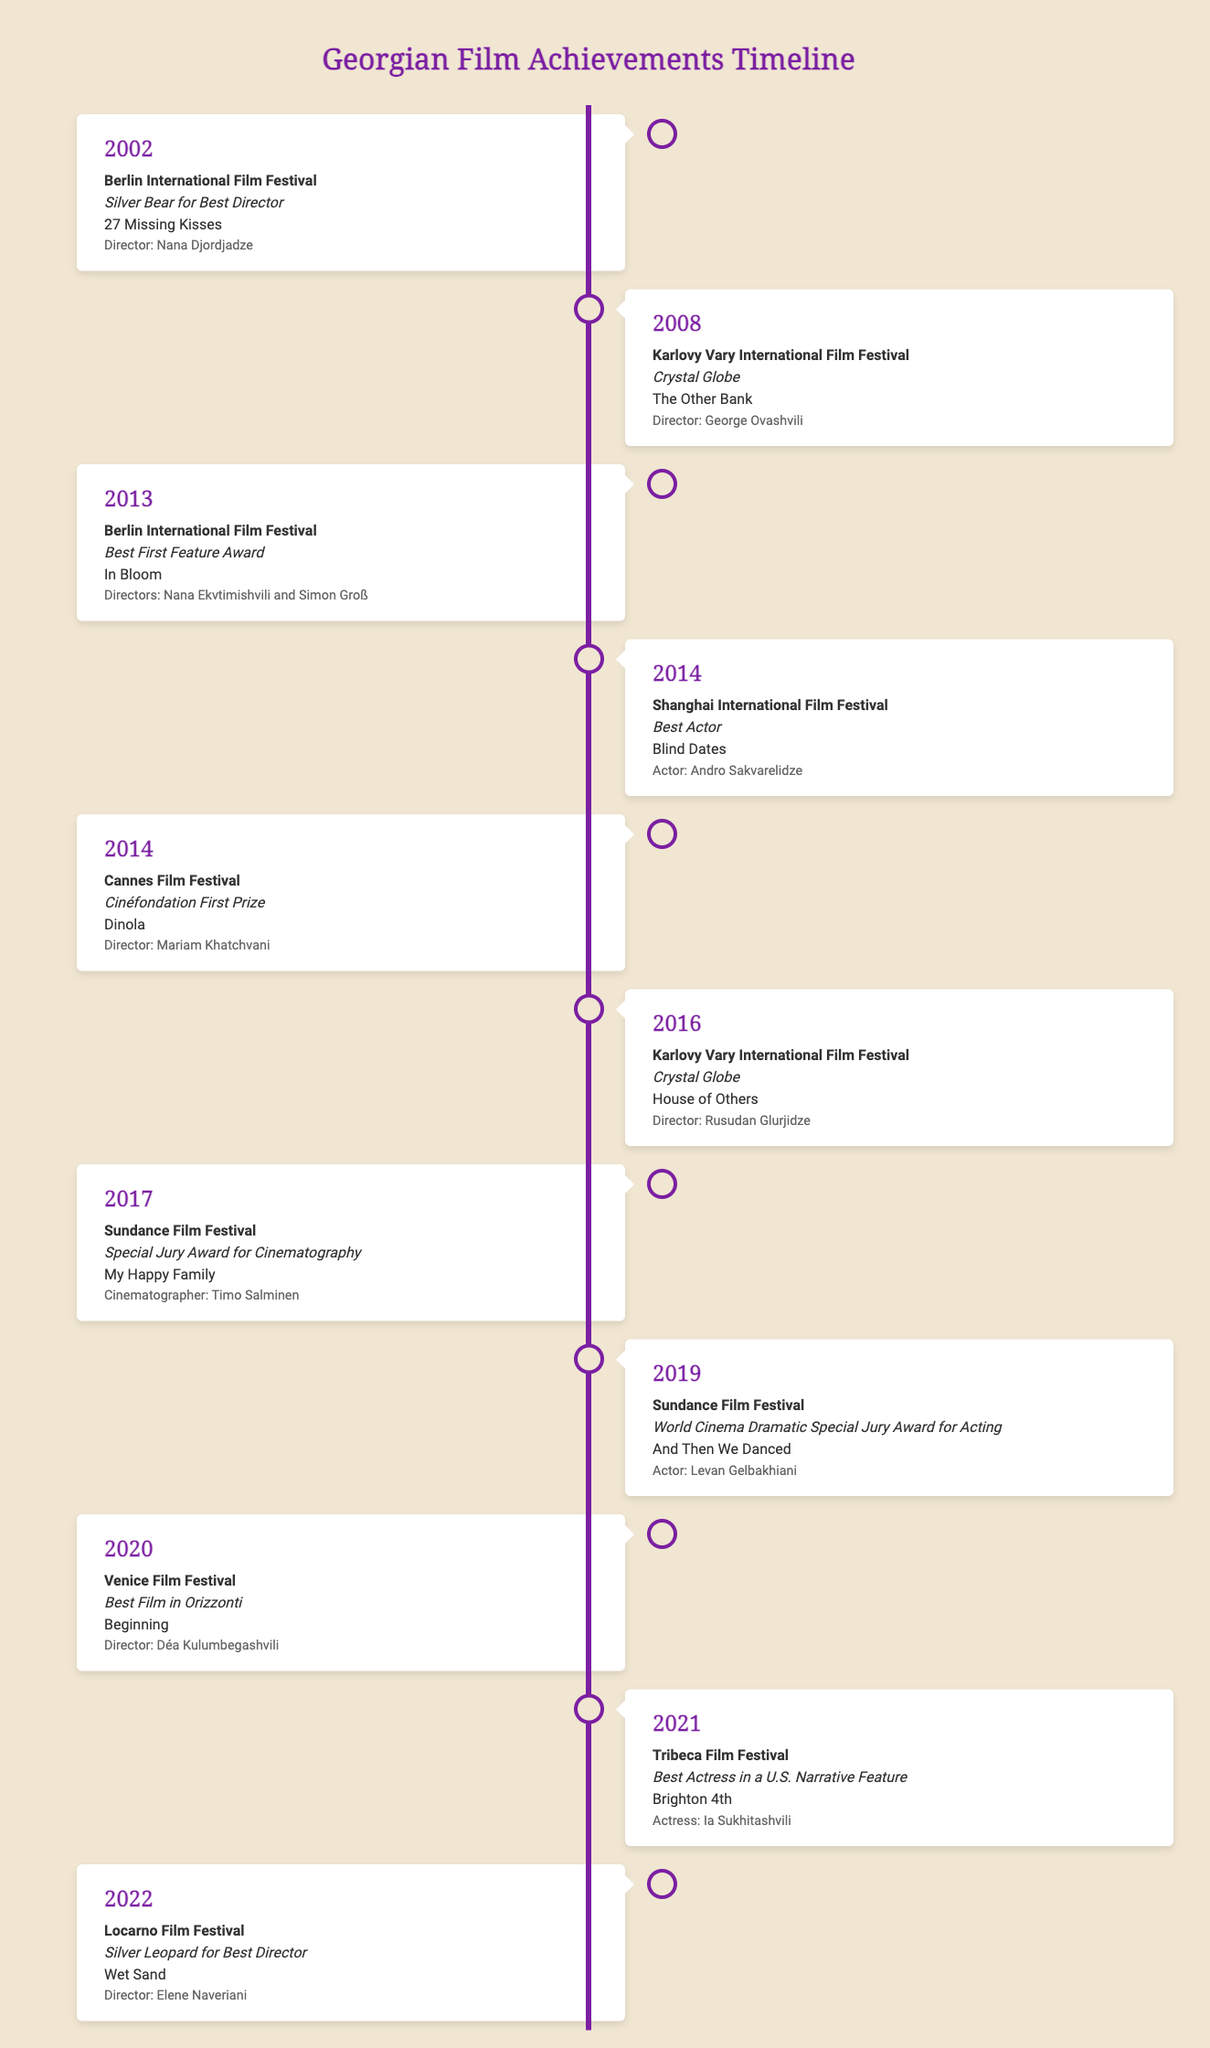What award did "27 Missing Kisses" win? The award won by "27 Missing Kisses" at the Berlin International Film Festival in 2002 is specified as the Silver Bear for Best Director.
Answer: Silver Bear for Best Director Who directed "In Bloom"? The directors of "In Bloom," which won the Best First Feature Award at the Berlin International Film Festival in 2013, are mentioned as Nana Ekvtimishvili and Simon Groß.
Answer: Nana Ekvtimishvili and Simon Groß What year did "The Other Bank" win the Crystal Globe? The year "The Other Bank" won the Crystal Globe at the Karlovy Vary International Film Festival is indicated as 2008.
Answer: 2008 Which film won the Best Film in Orizzonti at the Venice Film Festival? The film that won the Best Film in Orizzonti at the Venice Film Festival in 2020 is "Beginning," directed by Déa Kulumbegashvili.
Answer: Beginning Which actor won Best Actor for the film "Blind Dates"? The actor who received the Best Actor award for "Blind Dates" at the Shanghai International Film Festival in 2014 is Andro Sakvarelidze.
Answer: Andro Sakvarelidze How many times did Georgian films win at the Berlin International Film Festival by 2022? The timeline shows that Georgian films won at the Berlin International Film Festival in 2002 and 2013, making it twice.
Answer: 2 Which film at the 2016 Karlovy Vary International Film Festival won the Crystal Globe? The film that won the Crystal Globe at the Karlovy Vary International Film Festival in 2016 is "House of Others."
Answer: House of Others What major award did "Wet Sand" win in 2022? The award won by "Wet Sand" at the Locarno Film Festival in 2022 is mentioned as the Silver Leopard for Best Director.
Answer: Silver Leopard for Best Director 